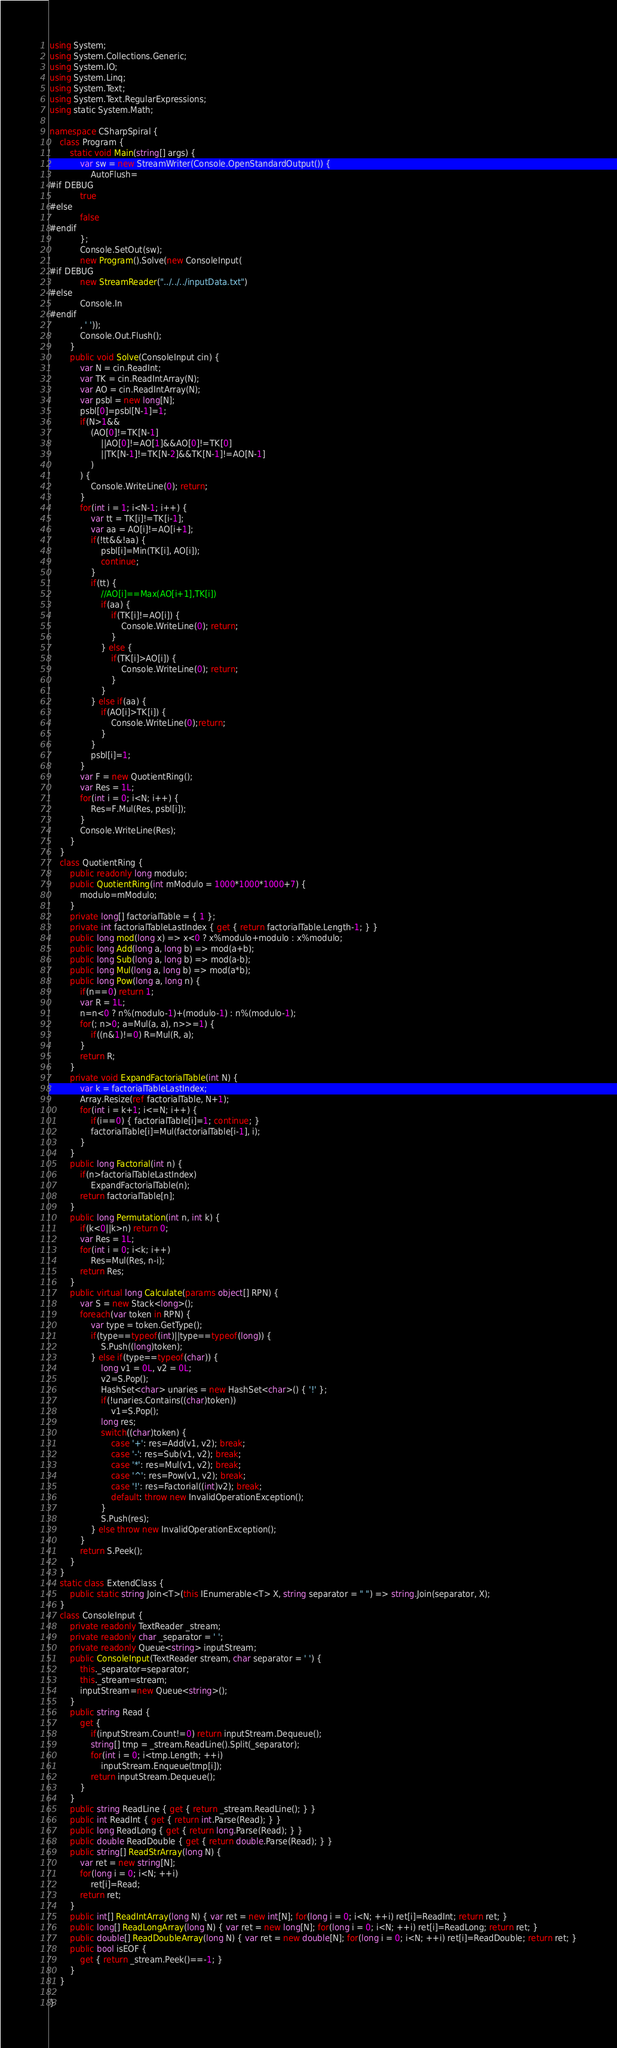Convert code to text. <code><loc_0><loc_0><loc_500><loc_500><_C#_>using System;
using System.Collections.Generic;
using System.IO;
using System.Linq;
using System.Text;
using System.Text.RegularExpressions;
using static System.Math;

namespace CSharpSpiral {
	class Program {
		static void Main(string[] args) {
			var sw = new StreamWriter(Console.OpenStandardOutput()) {
				AutoFlush=
#if DEBUG
			true
#else
			false
#endif
			};
			Console.SetOut(sw);
			new Program().Solve(new ConsoleInput(
#if DEBUG
			new StreamReader("../../../inputData.txt")
#else
			Console.In
#endif
			, ' '));
			Console.Out.Flush();
		}
		public void Solve(ConsoleInput cin) {
			var N = cin.ReadInt;
			var TK = cin.ReadIntArray(N);
			var AO = cin.ReadIntArray(N);
			var psbl = new long[N];
			psbl[0]=psbl[N-1]=1;
			if(N>1&&
				(AO[0]!=TK[N-1]
					||AO[0]!=AO[1]&&AO[0]!=TK[0]
					||TK[N-1]!=TK[N-2]&&TK[N-1]!=AO[N-1]
				)
			) {
				Console.WriteLine(0); return;
			}
			for(int i = 1; i<N-1; i++) {
				var tt = TK[i]!=TK[i-1];
				var aa = AO[i]!=AO[i+1];
				if(!tt&&!aa) {
					psbl[i]=Min(TK[i], AO[i]);
					continue;
				}
				if(tt) {
					//AO[i]==Max(AO[i+1],TK[i])
					if(aa) {
						if(TK[i]!=AO[i]) {
							Console.WriteLine(0); return;
						}
					} else {
						if(TK[i]>AO[i]) {
							Console.WriteLine(0); return;
						}
					}
				} else if(aa) {
					if(AO[i]>TK[i]) {
						Console.WriteLine(0);return;
					}
				}
				psbl[i]=1;
			}
			var F = new QuotientRing();
			var Res = 1L;
			for(int i = 0; i<N; i++) {
				Res=F.Mul(Res, psbl[i]);
			}
			Console.WriteLine(Res);
		}
	}
	class QuotientRing {
		public readonly long modulo;
		public QuotientRing(int mModulo = 1000*1000*1000+7) {
			modulo=mModulo;
		}
		private long[] factorialTable = { 1 };
		private int factorialTableLastIndex { get { return factorialTable.Length-1; } }
		public long mod(long x) => x<0 ? x%modulo+modulo : x%modulo;
		public long Add(long a, long b) => mod(a+b);
		public long Sub(long a, long b) => mod(a-b);
		public long Mul(long a, long b) => mod(a*b);
		public long Pow(long a, long n) {
			if(n==0) return 1;
			var R = 1L;
			n=n<0 ? n%(modulo-1)+(modulo-1) : n%(modulo-1);
			for(; n>0; a=Mul(a, a), n>>=1) {
				if((n&1)!=0) R=Mul(R, a);
			}
			return R;
		}
		private void ExpandFactorialTable(int N) {
			var k = factorialTableLastIndex;
			Array.Resize(ref factorialTable, N+1);
			for(int i = k+1; i<=N; i++) {
				if(i==0) { factorialTable[i]=1; continue; }
				factorialTable[i]=Mul(factorialTable[i-1], i);
			}
		}
		public long Factorial(int n) {
			if(n>factorialTableLastIndex)
				ExpandFactorialTable(n);
			return factorialTable[n];
		}
		public long Permutation(int n, int k) {
			if(k<0||k>n) return 0;
			var Res = 1L;
			for(int i = 0; i<k; i++)
				Res=Mul(Res, n-i);
			return Res;
		}
		public virtual long Calculate(params object[] RPN) {
			var S = new Stack<long>();
			foreach(var token in RPN) {
				var type = token.GetType();
				if(type==typeof(int)||type==typeof(long)) {
					S.Push((long)token);
				} else if(type==typeof(char)) {
					long v1 = 0L, v2 = 0L;
					v2=S.Pop();
					HashSet<char> unaries = new HashSet<char>() { '!' };
					if(!unaries.Contains((char)token))
						v1=S.Pop();
					long res;
					switch((char)token) {
						case '+': res=Add(v1, v2); break;
						case '-': res=Sub(v1, v2); break;
						case '*': res=Mul(v1, v2); break;
						case '^': res=Pow(v1, v2); break;
						case '!': res=Factorial((int)v2); break;
						default: throw new InvalidOperationException();
					}
					S.Push(res);
				} else throw new InvalidOperationException();
			}
			return S.Peek();
		}
	}
	static class ExtendClass {
		public static string Join<T>(this IEnumerable<T> X, string separator = " ") => string.Join(separator, X);
	}
	class ConsoleInput {
		private readonly TextReader _stream;
		private readonly char _separator = ' ';
		private readonly Queue<string> inputStream;
		public ConsoleInput(TextReader stream, char separator = ' ') {
			this._separator=separator;
			this._stream=stream;
			inputStream=new Queue<string>();
		}
		public string Read {
			get {
				if(inputStream.Count!=0) return inputStream.Dequeue();
				string[] tmp = _stream.ReadLine().Split(_separator);
				for(int i = 0; i<tmp.Length; ++i)
					inputStream.Enqueue(tmp[i]);
				return inputStream.Dequeue();
			}
		}
		public string ReadLine { get { return _stream.ReadLine(); } }
		public int ReadInt { get { return int.Parse(Read); } }
		public long ReadLong { get { return long.Parse(Read); } }
		public double ReadDouble { get { return double.Parse(Read); } }
		public string[] ReadStrArray(long N) {
			var ret = new string[N];
			for(long i = 0; i<N; ++i)
				ret[i]=Read;
			return ret;
		}
		public int[] ReadIntArray(long N) { var ret = new int[N]; for(long i = 0; i<N; ++i) ret[i]=ReadInt; return ret; }
		public long[] ReadLongArray(long N) { var ret = new long[N]; for(long i = 0; i<N; ++i) ret[i]=ReadLong; return ret; }
		public double[] ReadDoubleArray(long N) { var ret = new double[N]; for(long i = 0; i<N; ++i) ret[i]=ReadDouble; return ret; }
		public bool isEOF {
			get { return _stream.Peek()==-1; }
		}
	}

}</code> 